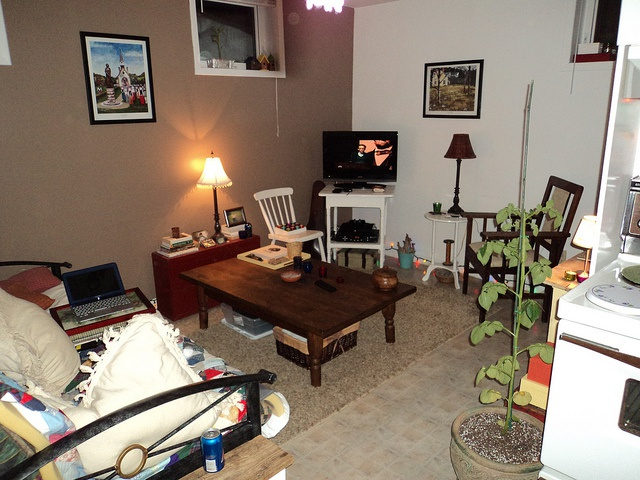Describe the objects in this image and their specific colors. I can see couch in gray, ivory, black, tan, and darkgray tones, oven in gray, white, darkgray, and black tones, potted plant in gray, olive, darkgreen, and black tones, dining table in gray, black, maroon, and tan tones, and chair in gray, black, darkgray, and olive tones in this image. 